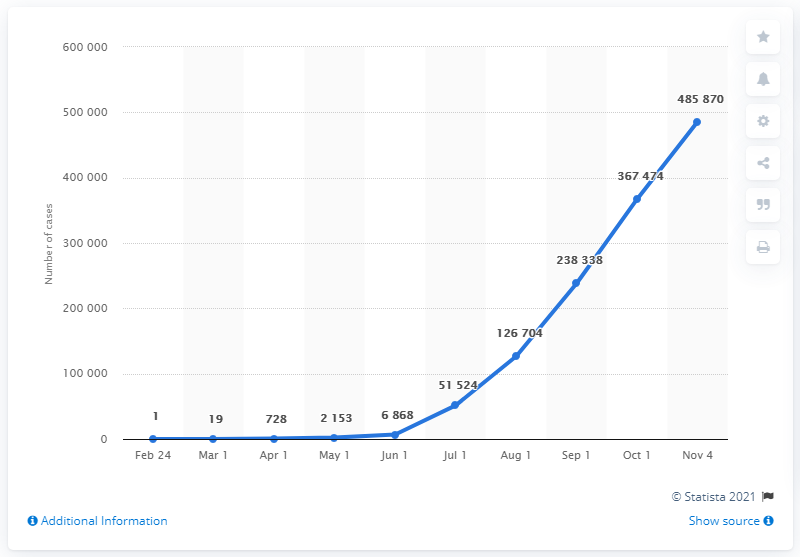Identify some key points in this picture. As of November 4, 2020, there have been a total of 485,870 cases of COVID-19 in Iraq. 